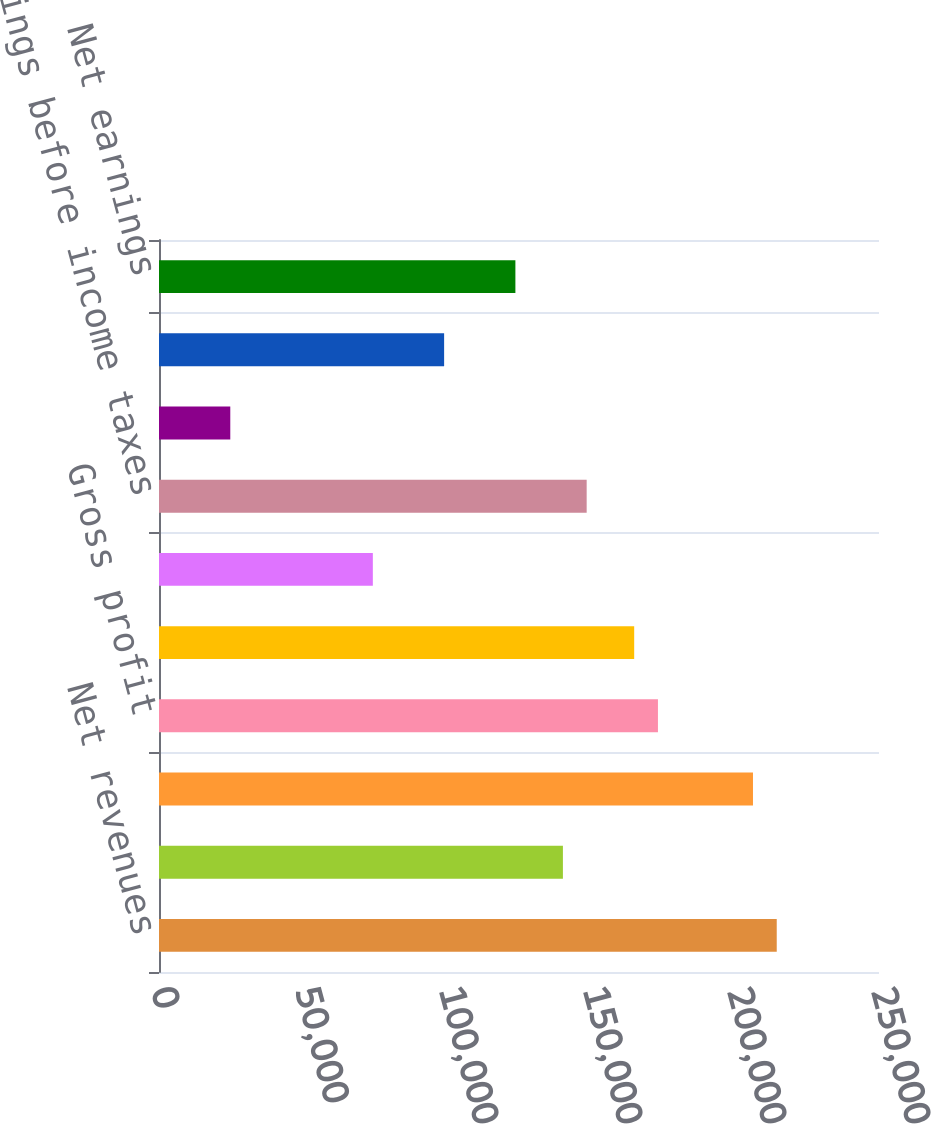Convert chart. <chart><loc_0><loc_0><loc_500><loc_500><bar_chart><fcel>Net revenues<fcel>Cost of sales<fcel>Excise taxes on products<fcel>Gross profit<fcel>Operating income<fcel>Interest expense net<fcel>Earnings before income taxes<fcel>Pre-tax profit margin<fcel>Provision for income taxes<fcel>Net earnings<nl><fcel>214494<fcel>140247<fcel>206244<fcel>173246<fcel>164996<fcel>74250.4<fcel>148497<fcel>24752.7<fcel>98999.2<fcel>123748<nl></chart> 